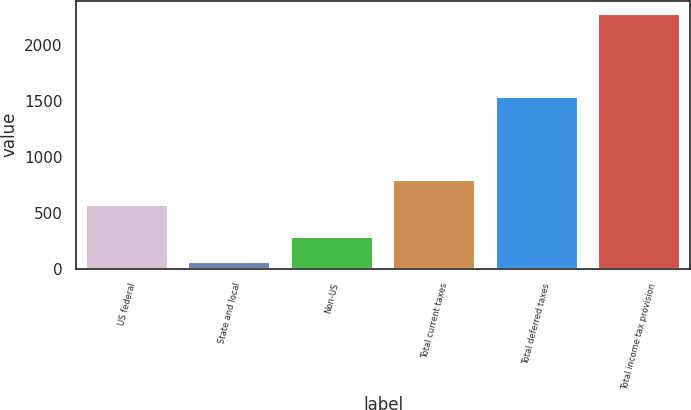Convert chart. <chart><loc_0><loc_0><loc_500><loc_500><bar_chart><fcel>US federal<fcel>State and local<fcel>Non-US<fcel>Total current taxes<fcel>Total deferred taxes<fcel>Total income tax provision<nl><fcel>568<fcel>58<fcel>279.9<fcel>789.9<fcel>1528<fcel>2277<nl></chart> 